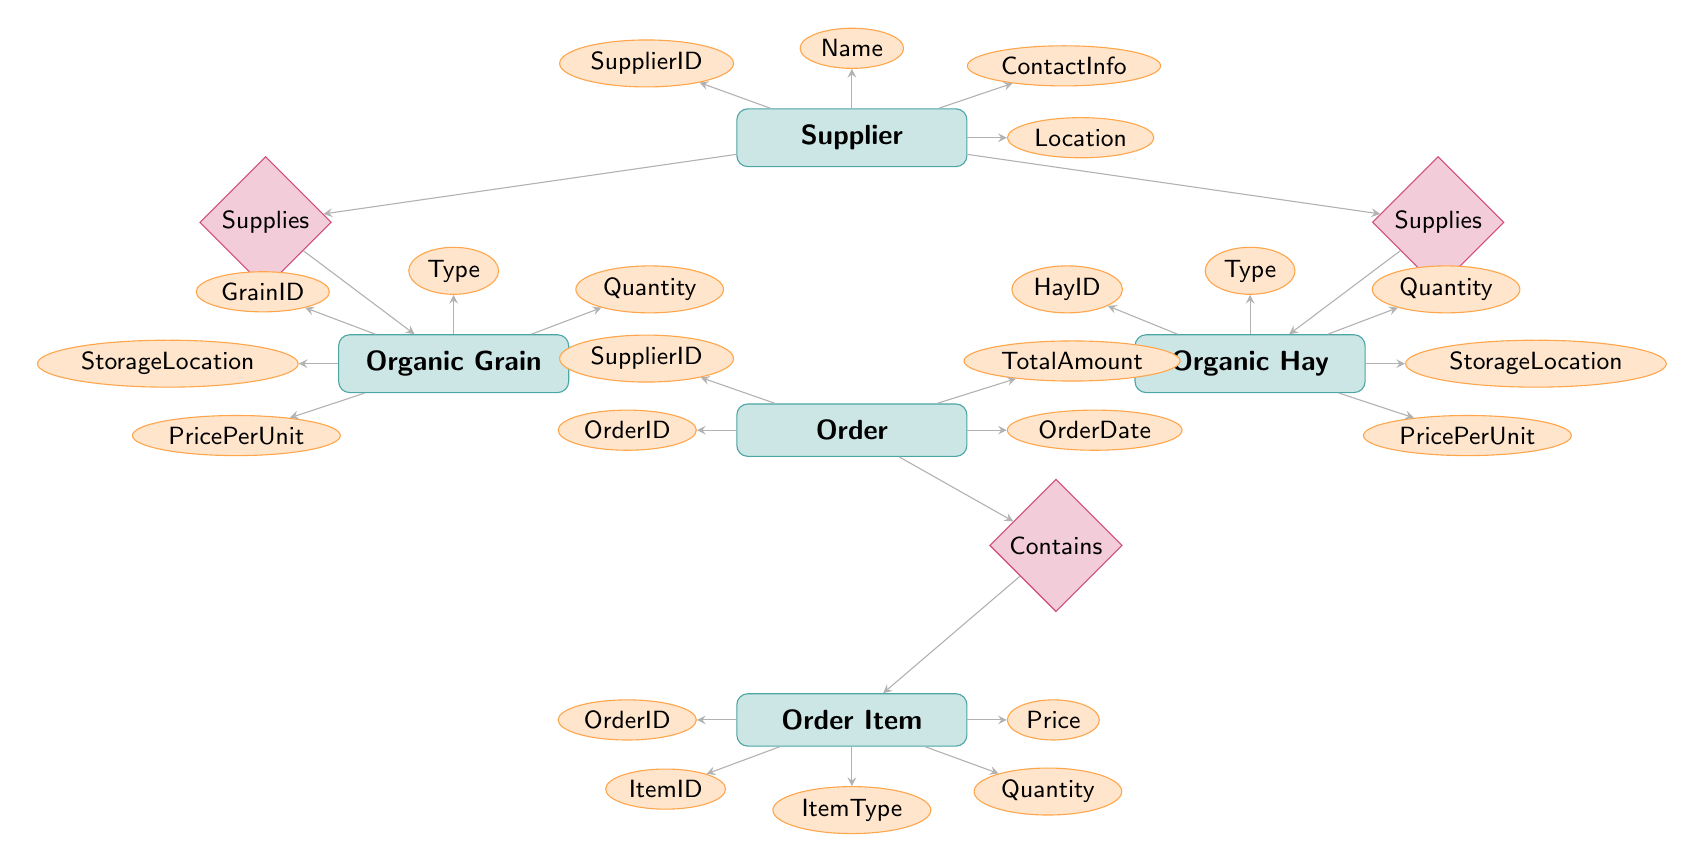What entities are present in the diagram? The entities in the diagram are shown as rectangles, labeled as Supplier, Organic Hay, Organic Grain, Order, and Order Item.
Answer: Supplier, Organic Hay, Organic Grain, Order, Order Item How many relationships are there in the diagram? There are three relationships shown as diamonds connecting the entities: Supplies (for both Organic Hay and Organic Grain) and Contains.
Answer: Three What attribute belongs to the Order entity? The attributes connected to the Order entity include OrderID, OrderDate, SupplierID, and TotalAmount, as shown by ellipses branching from the Order rectangle.
Answer: OrderID, OrderDate, SupplierID, TotalAmount Which entity is related to both Organic Hay and Organic Grain? The Supplier entity is related to both Organic Hay and Organic Grain through the Supplies relationship. This is indicated by the connecting lines to the respective entities.
Answer: Supplier What is the total number of attributes for the OrganicHay entity? The Organic Hay entity has five attributes, including HayID, Type, Quantity, StorageLocation, and PricePerUnit, as shown by the connecting ellipses.
Answer: Five What does the Contains relationship signify in this diagram? The Contains relationship indicates that an Order can include multiple Order Items. This is shown by the arrow from the Order entity to the Contains diamond and then to the Order Item entity.
Answer: An Order includes Order Items Which entity has the StorageLocation attribute? Both Organic Hay and Organic Grain entities have the StorageLocation attribute, indicated by their respective connections to that attribute.
Answer: Organic Hay, Organic Grain Is the SupplierID attribute present in both the Order and Supplier entities? Yes, the SupplierID attribute is present in both the Order entity (as an attribute) and as an identification key in the Supplier entity (for linking).
Answer: Yes What type of entity is OrderItem? Order Item is a type of entity in this diagram, as it is represented by a rectangle and contains attributes related to the items in an order.
Answer: Entity 